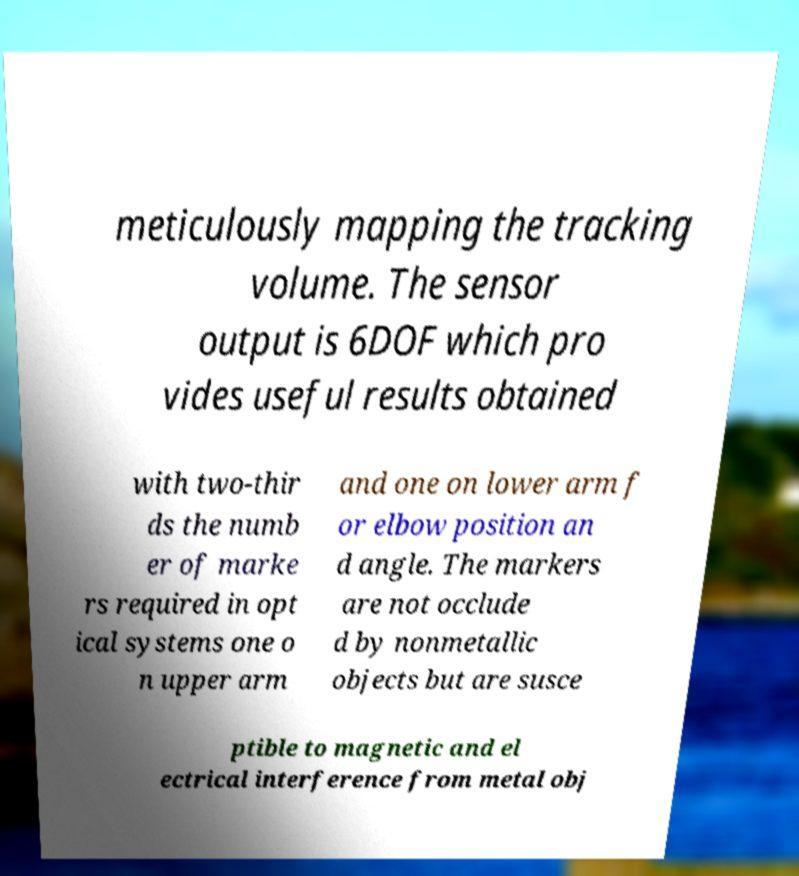For documentation purposes, I need the text within this image transcribed. Could you provide that? meticulously mapping the tracking volume. The sensor output is 6DOF which pro vides useful results obtained with two-thir ds the numb er of marke rs required in opt ical systems one o n upper arm and one on lower arm f or elbow position an d angle. The markers are not occlude d by nonmetallic objects but are susce ptible to magnetic and el ectrical interference from metal obj 